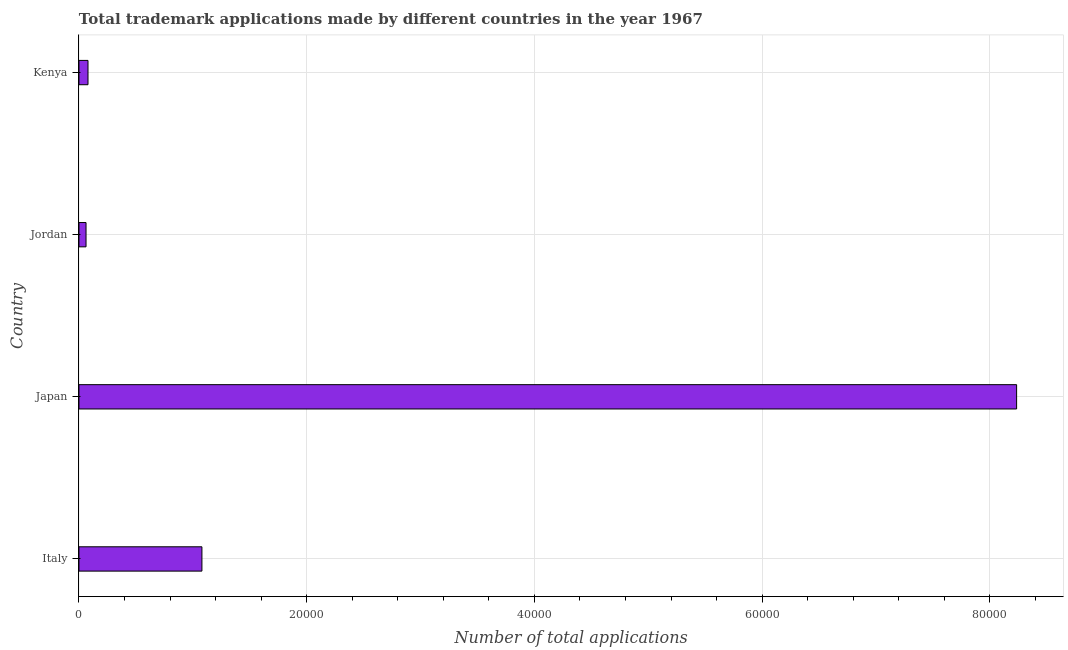Does the graph contain any zero values?
Offer a very short reply. No. What is the title of the graph?
Give a very brief answer. Total trademark applications made by different countries in the year 1967. What is the label or title of the X-axis?
Your response must be concise. Number of total applications. What is the label or title of the Y-axis?
Your answer should be very brief. Country. What is the number of trademark applications in Jordan?
Ensure brevity in your answer.  621. Across all countries, what is the maximum number of trademark applications?
Offer a terse response. 8.23e+04. Across all countries, what is the minimum number of trademark applications?
Provide a short and direct response. 621. In which country was the number of trademark applications minimum?
Your answer should be very brief. Jordan. What is the sum of the number of trademark applications?
Your answer should be very brief. 9.46e+04. What is the difference between the number of trademark applications in Japan and Jordan?
Give a very brief answer. 8.17e+04. What is the average number of trademark applications per country?
Keep it short and to the point. 2.36e+04. What is the median number of trademark applications?
Ensure brevity in your answer.  5796.5. In how many countries, is the number of trademark applications greater than 4000 ?
Your answer should be compact. 2. What is the ratio of the number of trademark applications in Italy to that in Kenya?
Provide a succinct answer. 13.6. What is the difference between the highest and the second highest number of trademark applications?
Your response must be concise. 7.15e+04. What is the difference between the highest and the lowest number of trademark applications?
Offer a very short reply. 8.17e+04. In how many countries, is the number of trademark applications greater than the average number of trademark applications taken over all countries?
Keep it short and to the point. 1. How many bars are there?
Your answer should be very brief. 4. Are all the bars in the graph horizontal?
Your answer should be very brief. Yes. How many countries are there in the graph?
Ensure brevity in your answer.  4. Are the values on the major ticks of X-axis written in scientific E-notation?
Provide a short and direct response. No. What is the Number of total applications of Italy?
Provide a short and direct response. 1.08e+04. What is the Number of total applications in Japan?
Provide a succinct answer. 8.23e+04. What is the Number of total applications in Jordan?
Ensure brevity in your answer.  621. What is the Number of total applications in Kenya?
Your answer should be very brief. 794. What is the difference between the Number of total applications in Italy and Japan?
Your answer should be very brief. -7.15e+04. What is the difference between the Number of total applications in Italy and Jordan?
Your answer should be compact. 1.02e+04. What is the difference between the Number of total applications in Italy and Kenya?
Offer a very short reply. 1.00e+04. What is the difference between the Number of total applications in Japan and Jordan?
Provide a succinct answer. 8.17e+04. What is the difference between the Number of total applications in Japan and Kenya?
Make the answer very short. 8.16e+04. What is the difference between the Number of total applications in Jordan and Kenya?
Provide a short and direct response. -173. What is the ratio of the Number of total applications in Italy to that in Japan?
Keep it short and to the point. 0.13. What is the ratio of the Number of total applications in Italy to that in Jordan?
Provide a succinct answer. 17.39. What is the ratio of the Number of total applications in Italy to that in Kenya?
Provide a short and direct response. 13.6. What is the ratio of the Number of total applications in Japan to that in Jordan?
Your response must be concise. 132.6. What is the ratio of the Number of total applications in Japan to that in Kenya?
Offer a very short reply. 103.71. What is the ratio of the Number of total applications in Jordan to that in Kenya?
Offer a very short reply. 0.78. 